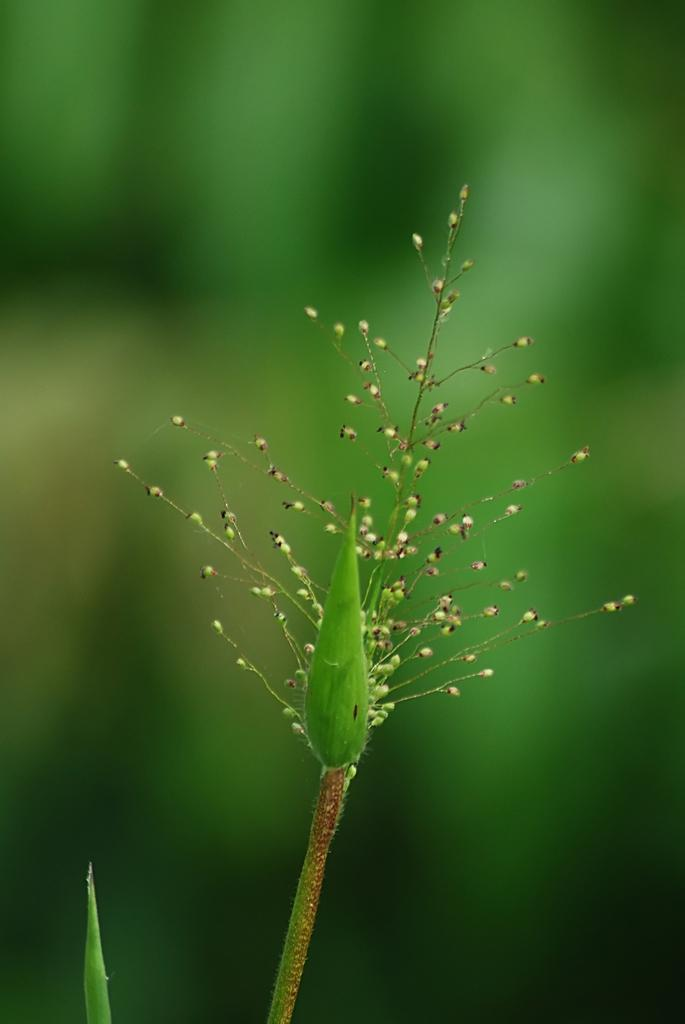What is the main subject of the image? The main subject of the image is a stem of a plant. What part of the plant can be seen in the image? There is a bud of a plant in the image. How would you describe the background of the image? The background of the image is blurred. What type of shirt is the person wearing in the image? There is no person present in the image, so it is not possible to determine what type of shirt they might be wearing. 